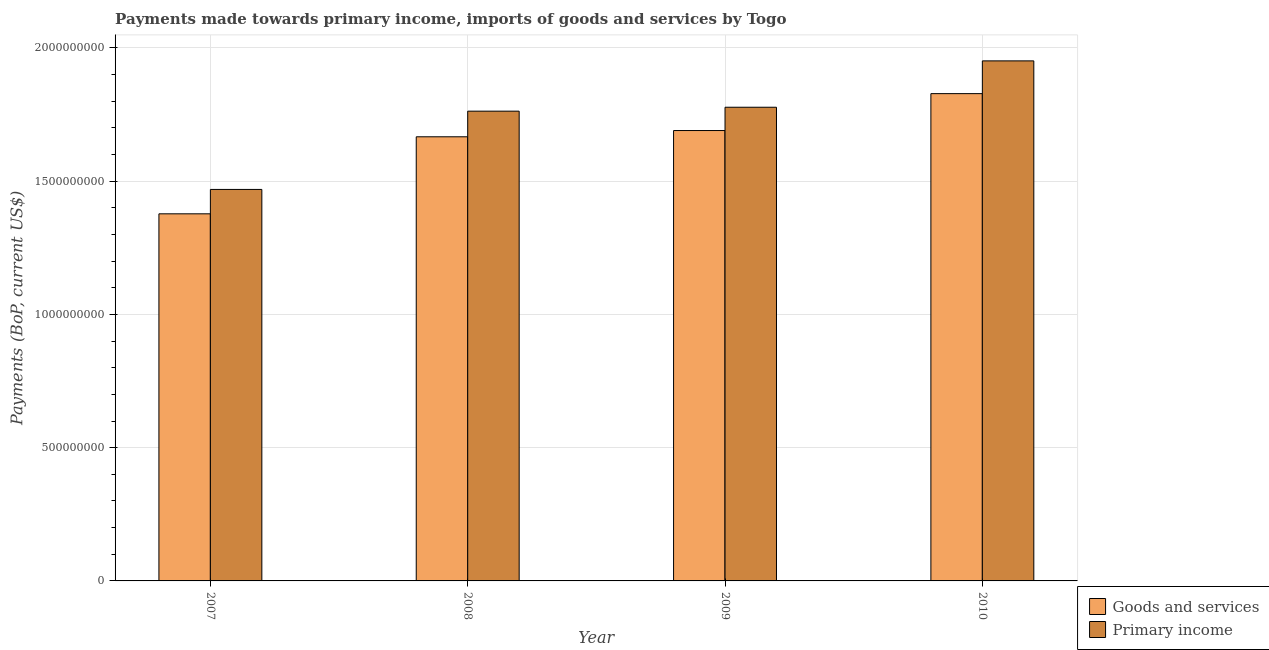Are the number of bars per tick equal to the number of legend labels?
Your response must be concise. Yes. How many bars are there on the 1st tick from the left?
Offer a terse response. 2. How many bars are there on the 3rd tick from the right?
Provide a short and direct response. 2. What is the payments made towards primary income in 2008?
Provide a short and direct response. 1.76e+09. Across all years, what is the maximum payments made towards primary income?
Offer a terse response. 1.95e+09. Across all years, what is the minimum payments made towards primary income?
Give a very brief answer. 1.47e+09. What is the total payments made towards goods and services in the graph?
Keep it short and to the point. 6.56e+09. What is the difference between the payments made towards goods and services in 2008 and that in 2009?
Keep it short and to the point. -2.35e+07. What is the difference between the payments made towards goods and services in 2008 and the payments made towards primary income in 2007?
Ensure brevity in your answer.  2.89e+08. What is the average payments made towards primary income per year?
Offer a terse response. 1.74e+09. In the year 2007, what is the difference between the payments made towards goods and services and payments made towards primary income?
Give a very brief answer. 0. In how many years, is the payments made towards goods and services greater than 200000000 US$?
Ensure brevity in your answer.  4. What is the ratio of the payments made towards goods and services in 2007 to that in 2009?
Your answer should be compact. 0.82. What is the difference between the highest and the second highest payments made towards primary income?
Give a very brief answer. 1.74e+08. What is the difference between the highest and the lowest payments made towards goods and services?
Your response must be concise. 4.51e+08. What does the 2nd bar from the left in 2007 represents?
Provide a short and direct response. Primary income. What does the 2nd bar from the right in 2009 represents?
Ensure brevity in your answer.  Goods and services. How many bars are there?
Provide a succinct answer. 8. Are all the bars in the graph horizontal?
Keep it short and to the point. No. Are the values on the major ticks of Y-axis written in scientific E-notation?
Give a very brief answer. No. Does the graph contain grids?
Offer a terse response. Yes. How many legend labels are there?
Ensure brevity in your answer.  2. How are the legend labels stacked?
Provide a short and direct response. Vertical. What is the title of the graph?
Ensure brevity in your answer.  Payments made towards primary income, imports of goods and services by Togo. What is the label or title of the X-axis?
Your answer should be compact. Year. What is the label or title of the Y-axis?
Your answer should be very brief. Payments (BoP, current US$). What is the Payments (BoP, current US$) of Goods and services in 2007?
Provide a short and direct response. 1.38e+09. What is the Payments (BoP, current US$) in Primary income in 2007?
Offer a very short reply. 1.47e+09. What is the Payments (BoP, current US$) of Goods and services in 2008?
Ensure brevity in your answer.  1.67e+09. What is the Payments (BoP, current US$) in Primary income in 2008?
Provide a short and direct response. 1.76e+09. What is the Payments (BoP, current US$) in Goods and services in 2009?
Provide a succinct answer. 1.69e+09. What is the Payments (BoP, current US$) in Primary income in 2009?
Keep it short and to the point. 1.78e+09. What is the Payments (BoP, current US$) in Goods and services in 2010?
Provide a short and direct response. 1.83e+09. What is the Payments (BoP, current US$) in Primary income in 2010?
Offer a very short reply. 1.95e+09. Across all years, what is the maximum Payments (BoP, current US$) of Goods and services?
Provide a succinct answer. 1.83e+09. Across all years, what is the maximum Payments (BoP, current US$) of Primary income?
Make the answer very short. 1.95e+09. Across all years, what is the minimum Payments (BoP, current US$) of Goods and services?
Keep it short and to the point. 1.38e+09. Across all years, what is the minimum Payments (BoP, current US$) of Primary income?
Provide a short and direct response. 1.47e+09. What is the total Payments (BoP, current US$) of Goods and services in the graph?
Ensure brevity in your answer.  6.56e+09. What is the total Payments (BoP, current US$) of Primary income in the graph?
Your answer should be compact. 6.96e+09. What is the difference between the Payments (BoP, current US$) of Goods and services in 2007 and that in 2008?
Give a very brief answer. -2.89e+08. What is the difference between the Payments (BoP, current US$) in Primary income in 2007 and that in 2008?
Ensure brevity in your answer.  -2.94e+08. What is the difference between the Payments (BoP, current US$) in Goods and services in 2007 and that in 2009?
Offer a very short reply. -3.12e+08. What is the difference between the Payments (BoP, current US$) in Primary income in 2007 and that in 2009?
Make the answer very short. -3.08e+08. What is the difference between the Payments (BoP, current US$) of Goods and services in 2007 and that in 2010?
Provide a short and direct response. -4.51e+08. What is the difference between the Payments (BoP, current US$) in Primary income in 2007 and that in 2010?
Your response must be concise. -4.82e+08. What is the difference between the Payments (BoP, current US$) in Goods and services in 2008 and that in 2009?
Give a very brief answer. -2.35e+07. What is the difference between the Payments (BoP, current US$) of Primary income in 2008 and that in 2009?
Your answer should be compact. -1.47e+07. What is the difference between the Payments (BoP, current US$) of Goods and services in 2008 and that in 2010?
Your answer should be compact. -1.62e+08. What is the difference between the Payments (BoP, current US$) of Primary income in 2008 and that in 2010?
Keep it short and to the point. -1.89e+08. What is the difference between the Payments (BoP, current US$) of Goods and services in 2009 and that in 2010?
Offer a very short reply. -1.38e+08. What is the difference between the Payments (BoP, current US$) of Primary income in 2009 and that in 2010?
Make the answer very short. -1.74e+08. What is the difference between the Payments (BoP, current US$) of Goods and services in 2007 and the Payments (BoP, current US$) of Primary income in 2008?
Offer a terse response. -3.85e+08. What is the difference between the Payments (BoP, current US$) of Goods and services in 2007 and the Payments (BoP, current US$) of Primary income in 2009?
Provide a succinct answer. -4.00e+08. What is the difference between the Payments (BoP, current US$) in Goods and services in 2007 and the Payments (BoP, current US$) in Primary income in 2010?
Your answer should be compact. -5.74e+08. What is the difference between the Payments (BoP, current US$) of Goods and services in 2008 and the Payments (BoP, current US$) of Primary income in 2009?
Make the answer very short. -1.11e+08. What is the difference between the Payments (BoP, current US$) of Goods and services in 2008 and the Payments (BoP, current US$) of Primary income in 2010?
Provide a short and direct response. -2.85e+08. What is the difference between the Payments (BoP, current US$) of Goods and services in 2009 and the Payments (BoP, current US$) of Primary income in 2010?
Provide a short and direct response. -2.61e+08. What is the average Payments (BoP, current US$) in Goods and services per year?
Provide a short and direct response. 1.64e+09. What is the average Payments (BoP, current US$) in Primary income per year?
Provide a short and direct response. 1.74e+09. In the year 2007, what is the difference between the Payments (BoP, current US$) of Goods and services and Payments (BoP, current US$) of Primary income?
Provide a short and direct response. -9.15e+07. In the year 2008, what is the difference between the Payments (BoP, current US$) in Goods and services and Payments (BoP, current US$) in Primary income?
Offer a terse response. -9.62e+07. In the year 2009, what is the difference between the Payments (BoP, current US$) in Goods and services and Payments (BoP, current US$) in Primary income?
Ensure brevity in your answer.  -8.74e+07. In the year 2010, what is the difference between the Payments (BoP, current US$) in Goods and services and Payments (BoP, current US$) in Primary income?
Provide a short and direct response. -1.23e+08. What is the ratio of the Payments (BoP, current US$) of Goods and services in 2007 to that in 2008?
Make the answer very short. 0.83. What is the ratio of the Payments (BoP, current US$) of Primary income in 2007 to that in 2008?
Offer a very short reply. 0.83. What is the ratio of the Payments (BoP, current US$) in Goods and services in 2007 to that in 2009?
Provide a short and direct response. 0.82. What is the ratio of the Payments (BoP, current US$) of Primary income in 2007 to that in 2009?
Provide a succinct answer. 0.83. What is the ratio of the Payments (BoP, current US$) in Goods and services in 2007 to that in 2010?
Your answer should be compact. 0.75. What is the ratio of the Payments (BoP, current US$) of Primary income in 2007 to that in 2010?
Offer a terse response. 0.75. What is the ratio of the Payments (BoP, current US$) in Goods and services in 2008 to that in 2009?
Keep it short and to the point. 0.99. What is the ratio of the Payments (BoP, current US$) of Goods and services in 2008 to that in 2010?
Offer a very short reply. 0.91. What is the ratio of the Payments (BoP, current US$) in Primary income in 2008 to that in 2010?
Offer a very short reply. 0.9. What is the ratio of the Payments (BoP, current US$) of Goods and services in 2009 to that in 2010?
Ensure brevity in your answer.  0.92. What is the ratio of the Payments (BoP, current US$) of Primary income in 2009 to that in 2010?
Your answer should be very brief. 0.91. What is the difference between the highest and the second highest Payments (BoP, current US$) in Goods and services?
Your answer should be compact. 1.38e+08. What is the difference between the highest and the second highest Payments (BoP, current US$) of Primary income?
Your answer should be very brief. 1.74e+08. What is the difference between the highest and the lowest Payments (BoP, current US$) in Goods and services?
Keep it short and to the point. 4.51e+08. What is the difference between the highest and the lowest Payments (BoP, current US$) in Primary income?
Your answer should be very brief. 4.82e+08. 